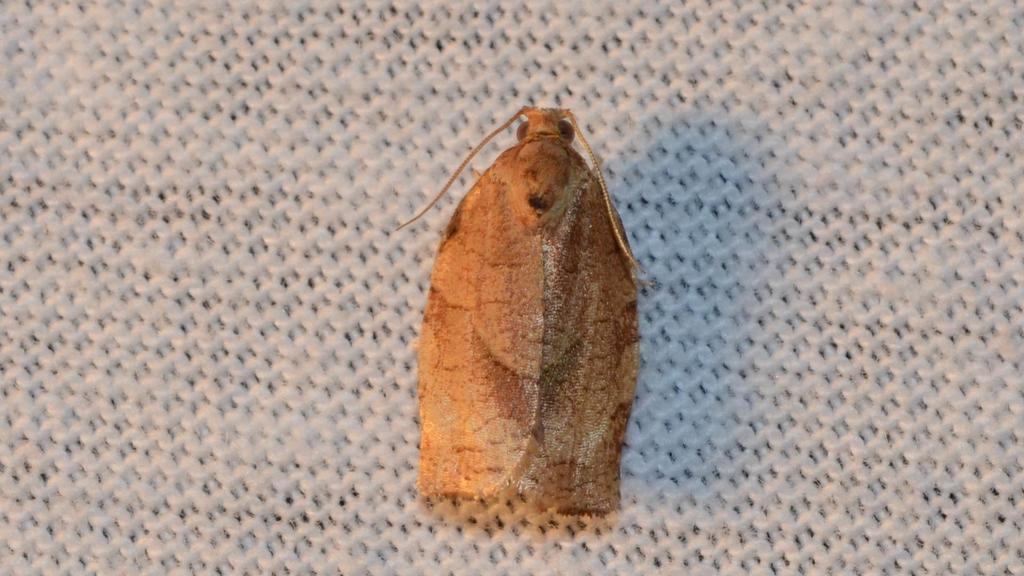What type of insect is in the image? There is a house moth in the image. Where is the house moth located? The house moth is on a path. What is the price of the house moth in the image? There is no price associated with the house moth in the image, as it is a living creature and not a product. 